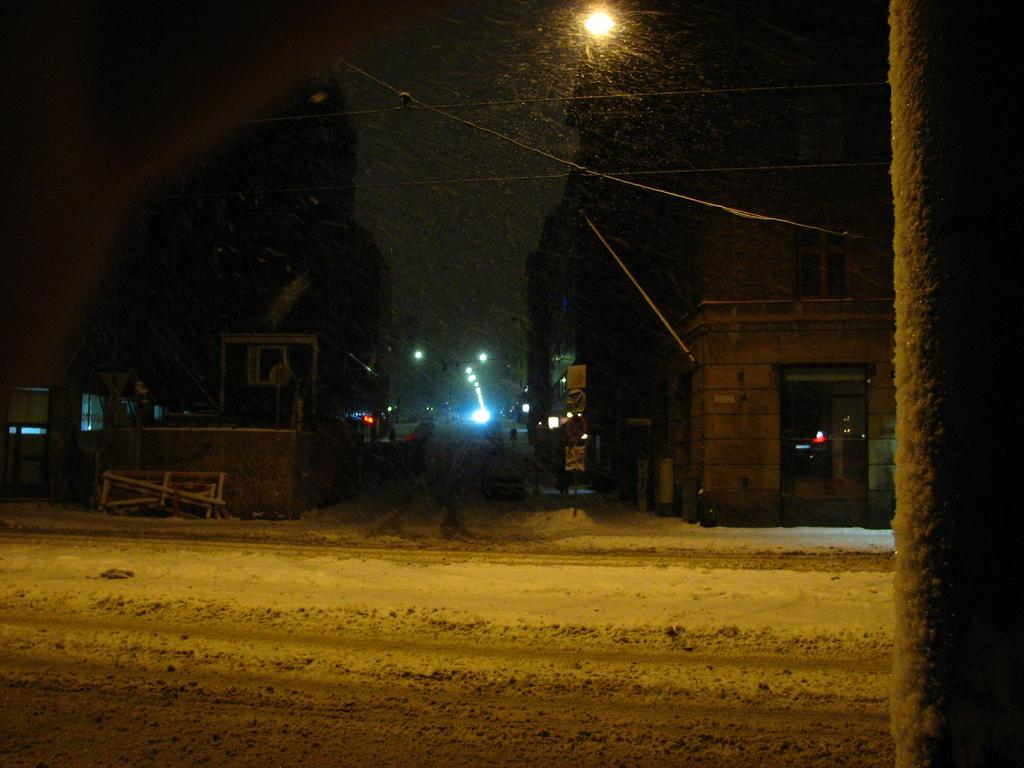What type of structures can be seen in the image? There are buildings in the image. What can be seen illuminating the scene in the image? There are lights in the image. What type of infrastructure is present in the image? There are cable wires in the image. What is the weather condition in the image? There is snow visible in the image. What is visible at the top of the image? The sky is visible in the image. Can you tell me how many frogs are sitting on the stem of the lights in the image? There are no frogs present in the image, and lights do not have stems. What type of verse can be heard being recited in the image? There is no indication in the image that any verses are being recited. 